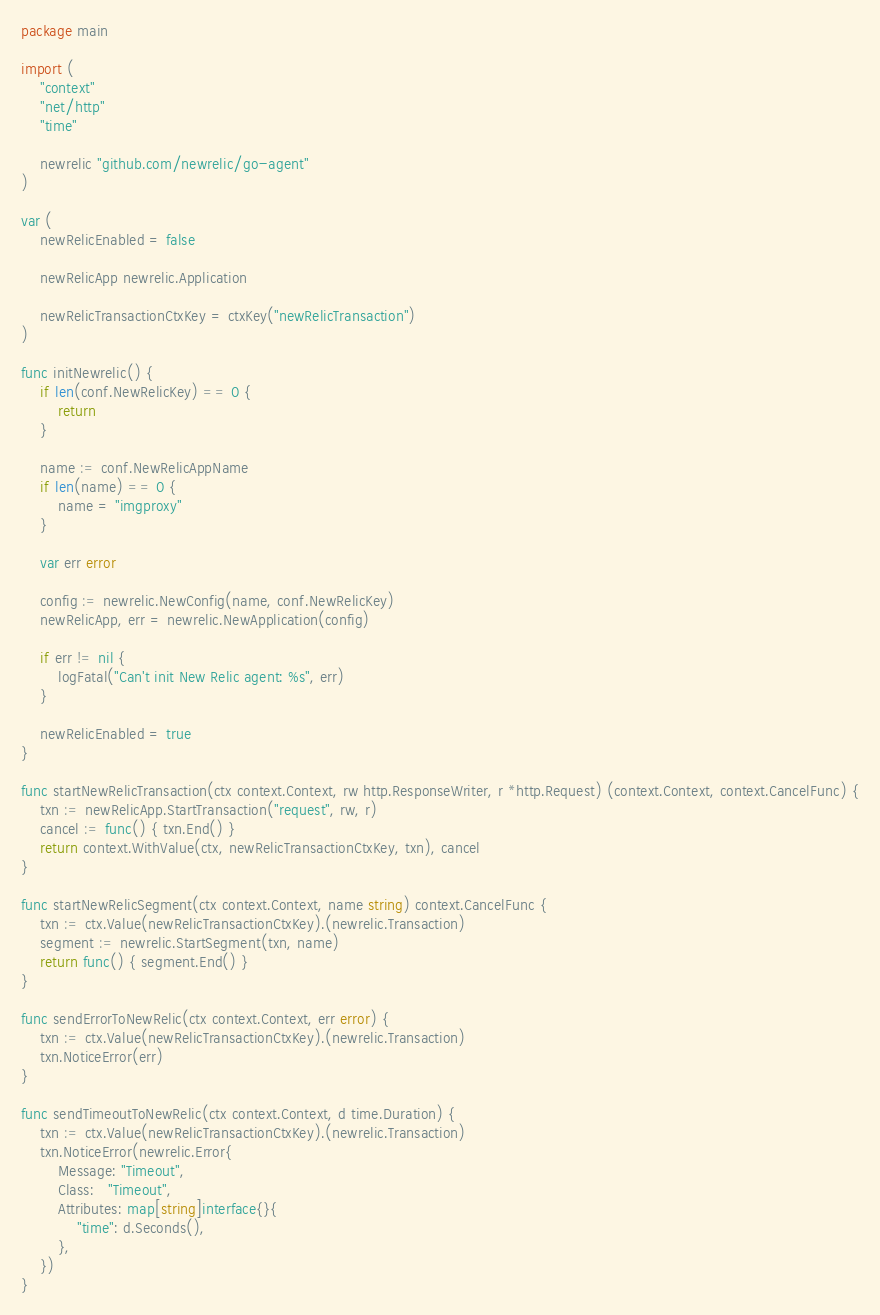<code> <loc_0><loc_0><loc_500><loc_500><_Go_>package main

import (
	"context"
	"net/http"
	"time"

	newrelic "github.com/newrelic/go-agent"
)

var (
	newRelicEnabled = false

	newRelicApp newrelic.Application

	newRelicTransactionCtxKey = ctxKey("newRelicTransaction")
)

func initNewrelic() {
	if len(conf.NewRelicKey) == 0 {
		return
	}

	name := conf.NewRelicAppName
	if len(name) == 0 {
		name = "imgproxy"
	}

	var err error

	config := newrelic.NewConfig(name, conf.NewRelicKey)
	newRelicApp, err = newrelic.NewApplication(config)

	if err != nil {
		logFatal("Can't init New Relic agent: %s", err)
	}

	newRelicEnabled = true
}

func startNewRelicTransaction(ctx context.Context, rw http.ResponseWriter, r *http.Request) (context.Context, context.CancelFunc) {
	txn := newRelicApp.StartTransaction("request", rw, r)
	cancel := func() { txn.End() }
	return context.WithValue(ctx, newRelicTransactionCtxKey, txn), cancel
}

func startNewRelicSegment(ctx context.Context, name string) context.CancelFunc {
	txn := ctx.Value(newRelicTransactionCtxKey).(newrelic.Transaction)
	segment := newrelic.StartSegment(txn, name)
	return func() { segment.End() }
}

func sendErrorToNewRelic(ctx context.Context, err error) {
	txn := ctx.Value(newRelicTransactionCtxKey).(newrelic.Transaction)
	txn.NoticeError(err)
}

func sendTimeoutToNewRelic(ctx context.Context, d time.Duration) {
	txn := ctx.Value(newRelicTransactionCtxKey).(newrelic.Transaction)
	txn.NoticeError(newrelic.Error{
		Message: "Timeout",
		Class:   "Timeout",
		Attributes: map[string]interface{}{
			"time": d.Seconds(),
		},
	})
}
</code> 